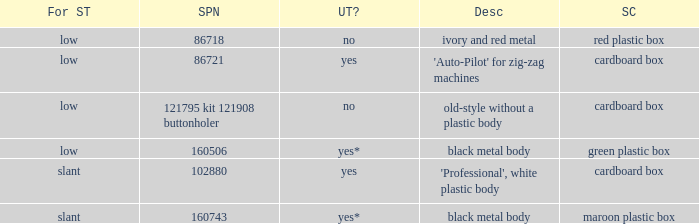What's the singer part number of the buttonholer whose storage case is a green plastic box? 160506.0. 